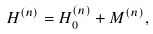<formula> <loc_0><loc_0><loc_500><loc_500>H ^ { ( n ) } = H _ { 0 } ^ { ( n ) } + M ^ { ( n ) } ,</formula> 